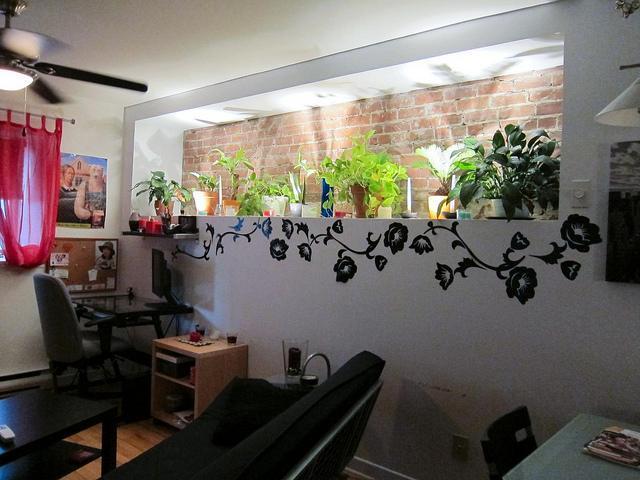How many lights are in the ceiling?
Give a very brief answer. 1. How many dining tables can you see?
Give a very brief answer. 2. How many chairs are visible?
Give a very brief answer. 2. How many potted plants are there?
Give a very brief answer. 2. 